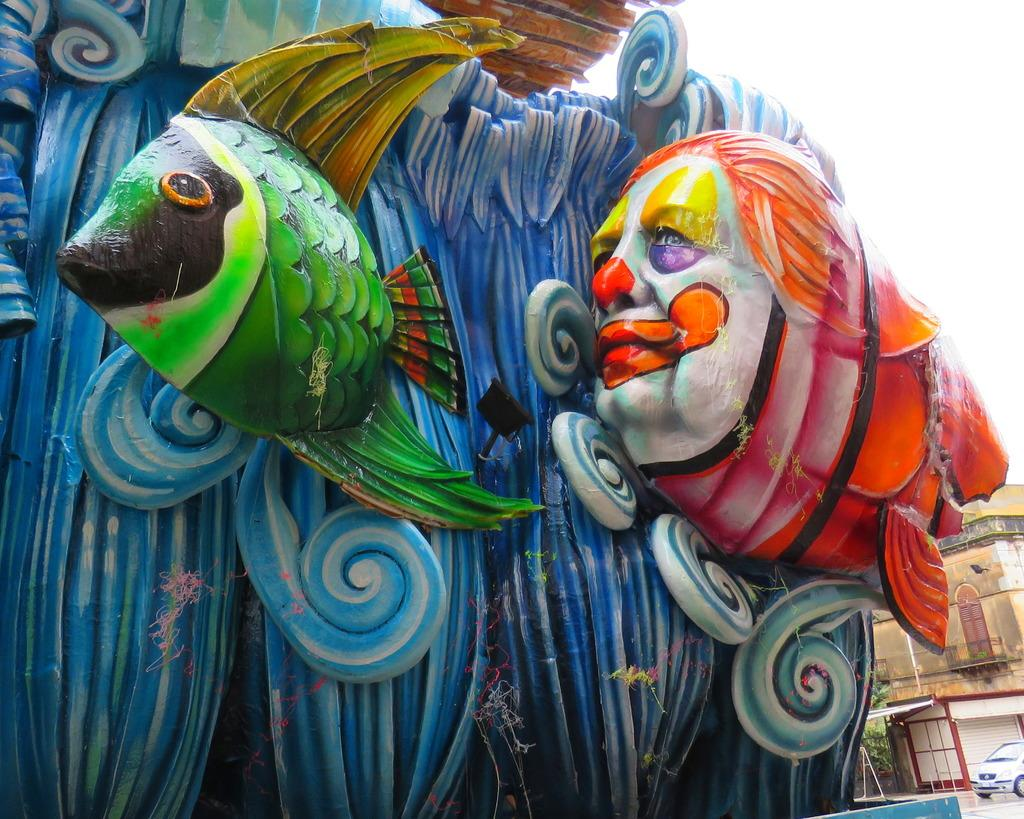What is the main subject of the painting in the foreground of the picture? There is a painting of a fish in the foreground of the picture. What other features can be seen in the painting? There is a person's face in the painting. What type of structure is visible in the picture? There is a building in the picture. What mode of transportation can be seen in the bottom right side of the picture? There is a car in the bottom right side of the picture. What type of frog can be seen sitting on the person's face in the painting? There is no frog present in the painting; it features a fish and a person's face. What credit card company is sponsoring the painting in the image? There is no information about any credit card company sponsoring the painting in the image. 